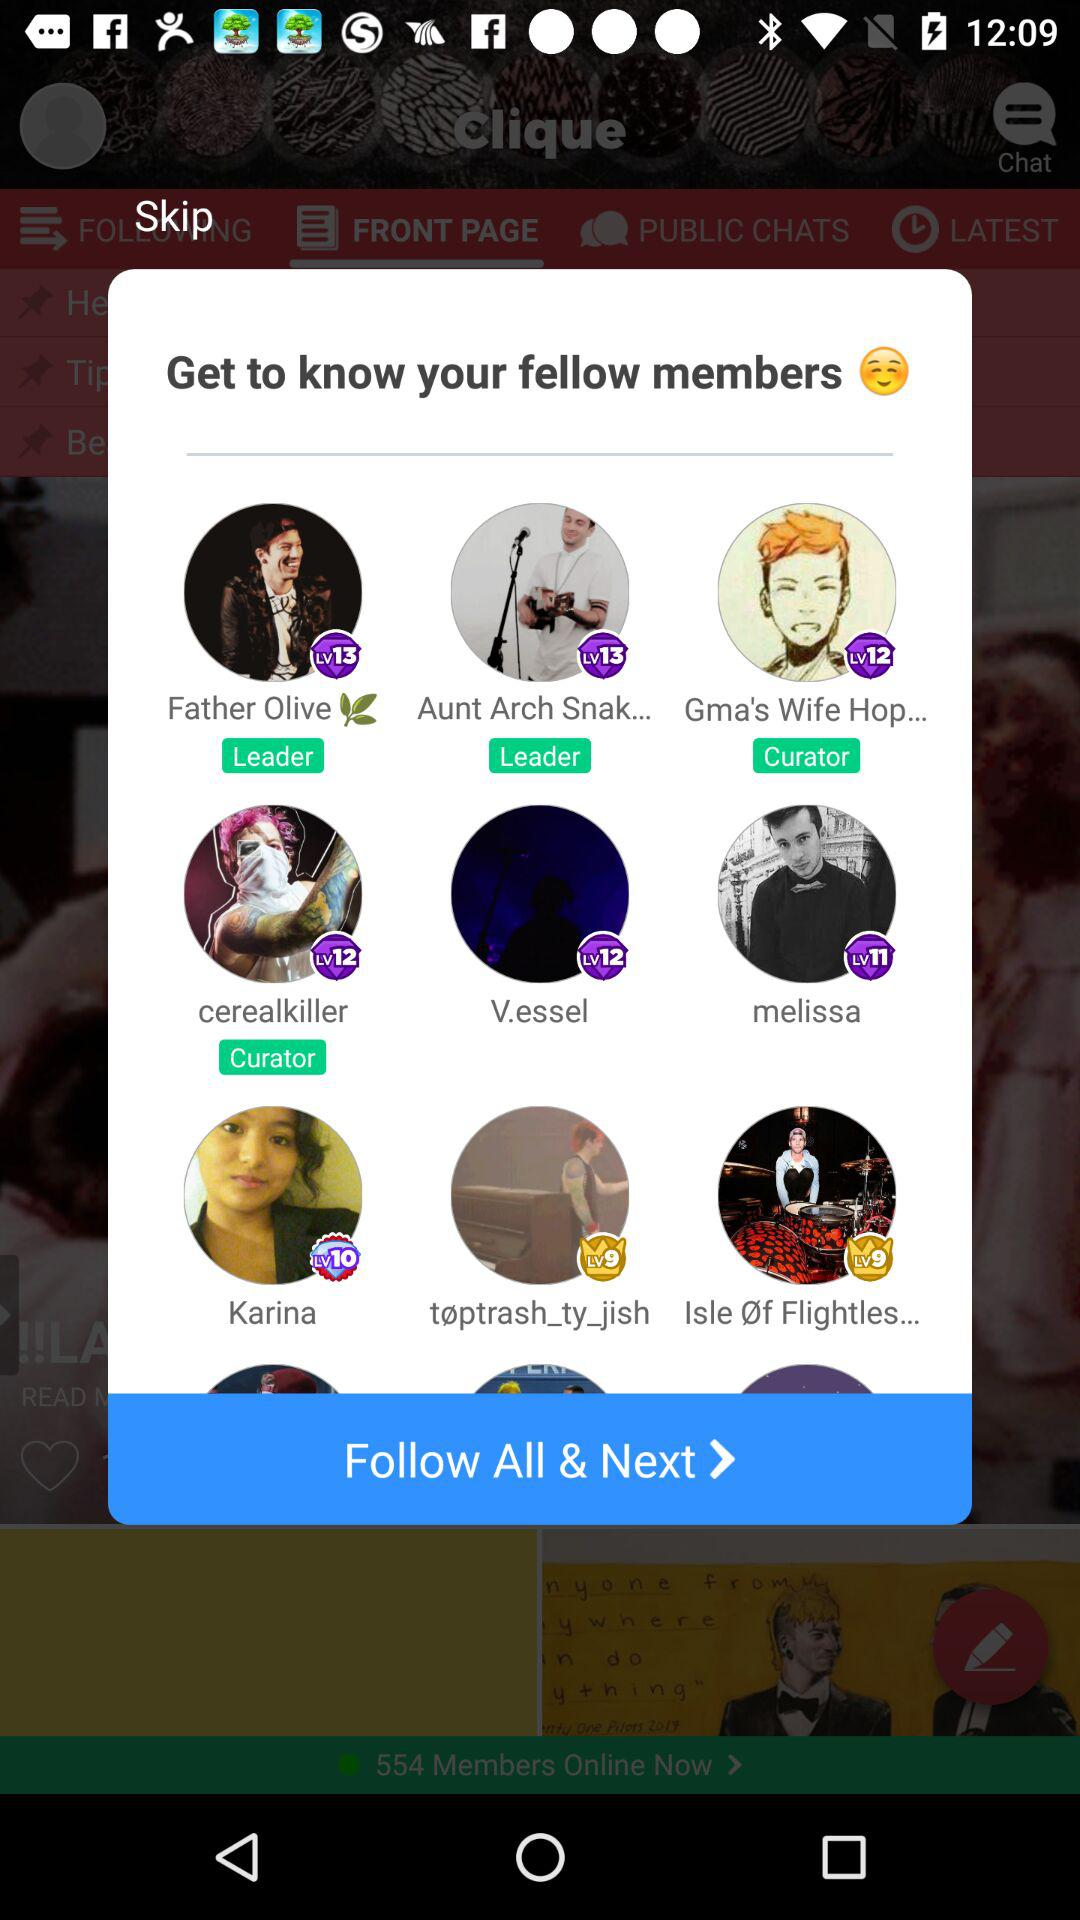What is the role of "Father Olive"? The role of "Father Olive" is that of a leader. 